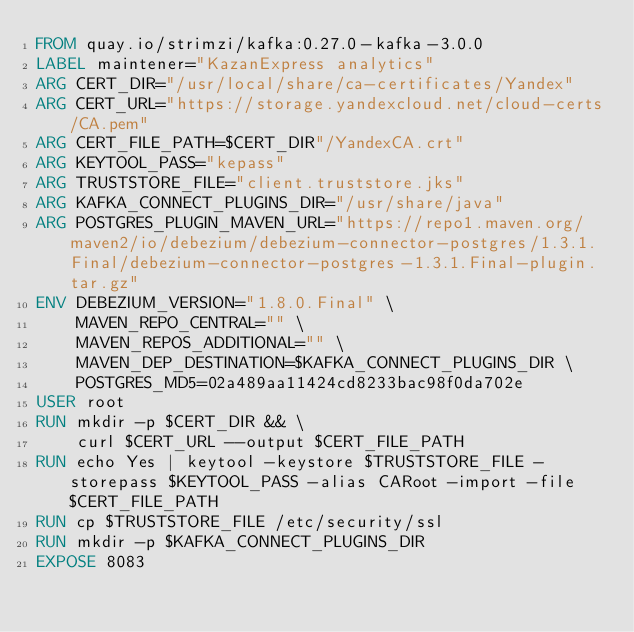<code> <loc_0><loc_0><loc_500><loc_500><_Dockerfile_>FROM quay.io/strimzi/kafka:0.27.0-kafka-3.0.0
LABEL maintener="KazanExpress analytics"
ARG CERT_DIR="/usr/local/share/ca-certificates/Yandex"
ARG CERT_URL="https://storage.yandexcloud.net/cloud-certs/CA.pem"
ARG CERT_FILE_PATH=$CERT_DIR"/YandexCA.crt"
ARG KEYTOOL_PASS="kepass"
ARG TRUSTSTORE_FILE="client.truststore.jks"
ARG KAFKA_CONNECT_PLUGINS_DIR="/usr/share/java"
ARG POSTGRES_PLUGIN_MAVEN_URL="https://repo1.maven.org/maven2/io/debezium/debezium-connector-postgres/1.3.1.Final/debezium-connector-postgres-1.3.1.Final-plugin.tar.gz"
ENV DEBEZIUM_VERSION="1.8.0.Final" \
    MAVEN_REPO_CENTRAL="" \
    MAVEN_REPOS_ADDITIONAL="" \
    MAVEN_DEP_DESTINATION=$KAFKA_CONNECT_PLUGINS_DIR \
    POSTGRES_MD5=02a489aa11424cd8233bac98f0da702e
USER root
RUN mkdir -p $CERT_DIR && \
    curl $CERT_URL --output $CERT_FILE_PATH
RUN echo Yes | keytool -keystore $TRUSTSTORE_FILE -storepass $KEYTOOL_PASS -alias CARoot -import -file $CERT_FILE_PATH
RUN cp $TRUSTSTORE_FILE /etc/security/ssl
RUN mkdir -p $KAFKA_CONNECT_PLUGINS_DIR
EXPOSE 8083</code> 